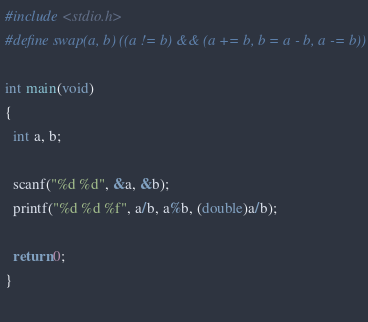Convert code to text. <code><loc_0><loc_0><loc_500><loc_500><_C_>#include <stdio.h>
#define swap(a, b) ((a != b) && (a += b, b = a - b, a -= b))

int main(void)
{
  int a, b;

  scanf("%d %d", &a, &b);
  printf("%d %d %f", a/b, a%b, (double)a/b);

  return 0;
}
    </code> 